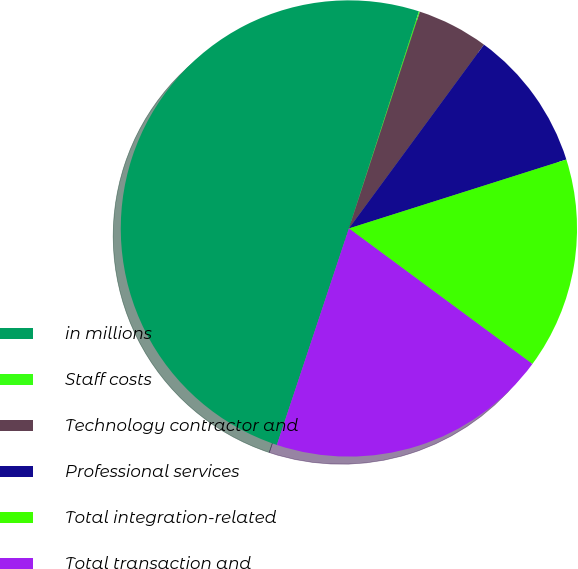<chart> <loc_0><loc_0><loc_500><loc_500><pie_chart><fcel>in millions<fcel>Staff costs<fcel>Technology contractor and<fcel>Professional services<fcel>Total integration-related<fcel>Total transaction and<nl><fcel>49.86%<fcel>0.07%<fcel>5.05%<fcel>10.03%<fcel>15.01%<fcel>19.99%<nl></chart> 